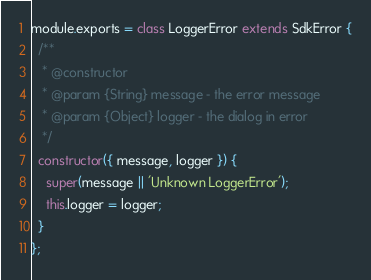<code> <loc_0><loc_0><loc_500><loc_500><_JavaScript_>
module.exports = class LoggerError extends SdkError {
  /**
   * @constructor
   * @param {String} message - the error message
   * @param {Object} logger - the dialog in error
   */
  constructor({ message, logger }) {
    super(message || 'Unknown LoggerError');
    this.logger = logger;
  }
};
</code> 